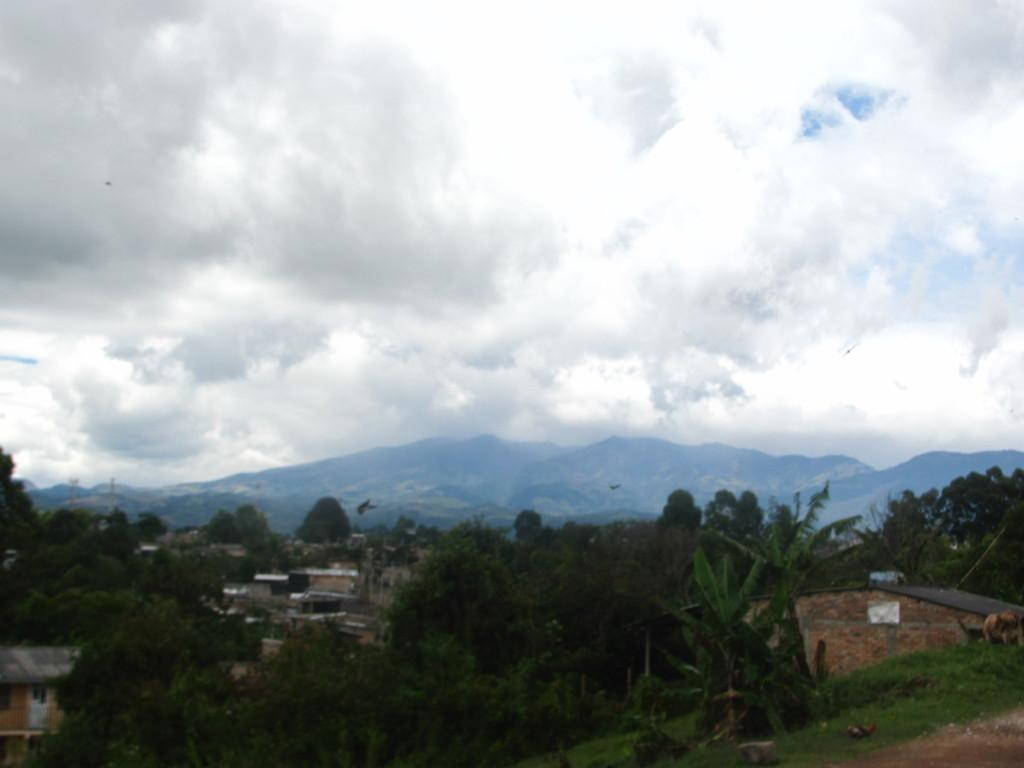What type of natural elements can be seen in the image? There are trees in the image. What type of man-made structures are present in the image? There are houses in the image. Where are the trees and houses located in the image? The trees and houses are located at the bottom of the image. What is visible at the top of the image? The sky is visible at the top of the image. What type of terrain can be seen on the right side of the image? There is sand on the right side of the image. What type of geographical feature is visible in the background of the image? There are mountains in the background of the image. What type of chain can be seen connecting the trees and houses in the image? There is no chain connecting the trees and houses in the image; the image only shows them as separate entities. How does the image capture the attention of the viewer? The image itself does not capture attention; it is a static representation of the scene. 